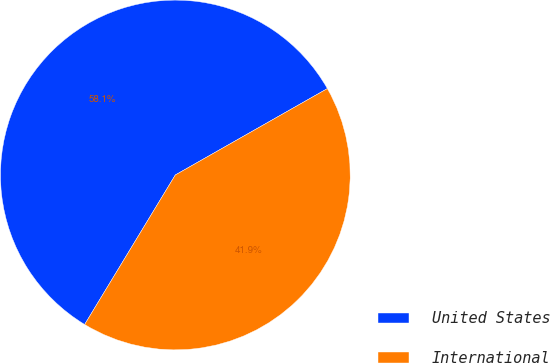<chart> <loc_0><loc_0><loc_500><loc_500><pie_chart><fcel>United States<fcel>International<nl><fcel>58.1%<fcel>41.9%<nl></chart> 